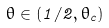Convert formula to latex. <formula><loc_0><loc_0><loc_500><loc_500>\theta \in ( 1 / 2 , \theta _ { c } )</formula> 